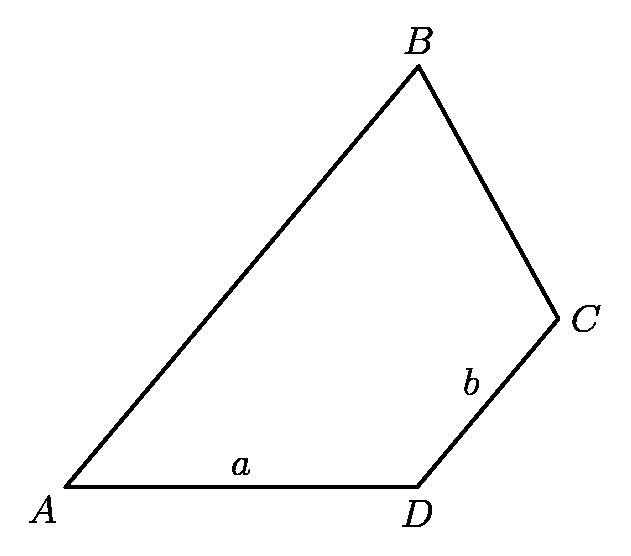Please explain why the measure of angle D is twice the measure of angle B in the given diagram. From the properties of parallel lines and their transversal, if segment AB is parallel to segment CD, then corresponding angles are congruent. The statement that the measure of angle D is twice the measure of angle B suggests an external factor such as angle duplication at the vertices, possibly angle B being an angle created by bisector or due to certain conditions set in the problem like scaling or type of triangle (e.g., isosceles). More context is required from the original problem setup to precisely describe this condition. 